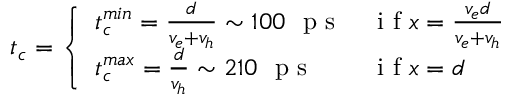<formula> <loc_0><loc_0><loc_500><loc_500>t _ { c } = \left \{ \begin{array} { l l } { t _ { c } ^ { \min } = \frac { d } { v _ { e } + v _ { h } } \sim 1 0 0 p s } & { i f x = \frac { v _ { e } d } { v _ { e } + v _ { h } } } \\ { t _ { c } ^ { \max } = \frac { d } { v _ { h } } \sim 2 1 0 p s } & { i f x = d } \end{array}</formula> 